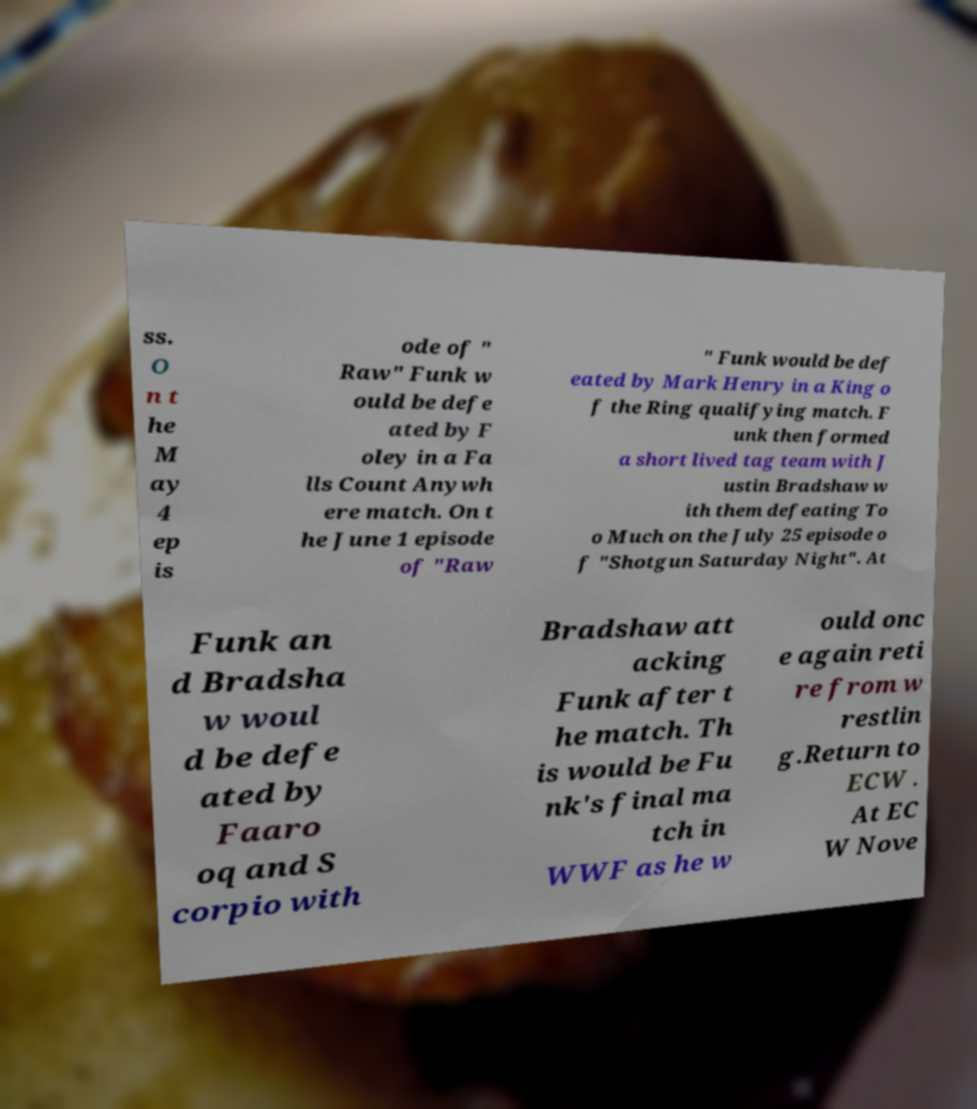Can you accurately transcribe the text from the provided image for me? ss. O n t he M ay 4 ep is ode of " Raw" Funk w ould be defe ated by F oley in a Fa lls Count Anywh ere match. On t he June 1 episode of "Raw " Funk would be def eated by Mark Henry in a King o f the Ring qualifying match. F unk then formed a short lived tag team with J ustin Bradshaw w ith them defeating To o Much on the July 25 episode o f "Shotgun Saturday Night". At Funk an d Bradsha w woul d be defe ated by Faaro oq and S corpio with Bradshaw att acking Funk after t he match. Th is would be Fu nk's final ma tch in WWF as he w ould onc e again reti re from w restlin g.Return to ECW . At EC W Nove 